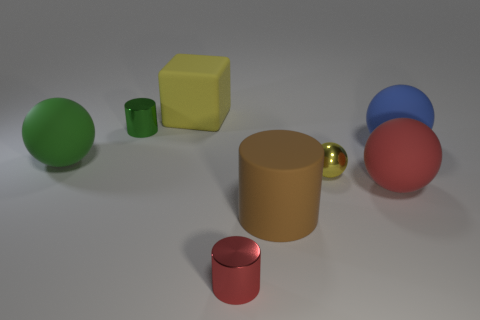What is the material of the brown cylinder?
Offer a very short reply. Rubber. How many tiny red metallic things are in front of the yellow object behind the yellow sphere?
Provide a succinct answer. 1. There is a block; is its color the same as the metallic cylinder in front of the large brown cylinder?
Your answer should be compact. No. What color is the block that is the same size as the rubber cylinder?
Your answer should be compact. Yellow. Are there any brown rubber objects of the same shape as the yellow metallic object?
Make the answer very short. No. Are there fewer big cyan objects than green cylinders?
Your answer should be very brief. Yes. There is a metallic cylinder that is behind the big red matte thing; what is its color?
Provide a short and direct response. Green. There is a red thing that is left of the large sphere in front of the green rubber ball; what is its shape?
Your answer should be very brief. Cylinder. Is the material of the large green sphere the same as the cylinder that is behind the yellow shiny sphere?
Ensure brevity in your answer.  No. What shape is the large object that is the same color as the tiny sphere?
Offer a very short reply. Cube. 